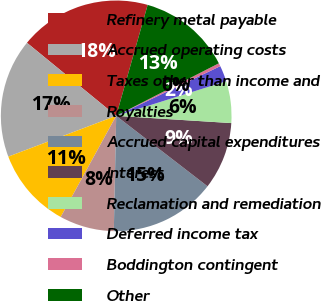Convert chart. <chart><loc_0><loc_0><loc_500><loc_500><pie_chart><fcel>Refinery metal payable<fcel>Accrued operating costs<fcel>Taxes other than income and<fcel>Royalties<fcel>Accrued capital expenditures<fcel>Interest<fcel>Reclamation and remediation<fcel>Deferred income tax<fcel>Boddington contingent<fcel>Other<nl><fcel>18.48%<fcel>16.67%<fcel>11.26%<fcel>7.66%<fcel>14.87%<fcel>9.46%<fcel>5.85%<fcel>2.24%<fcel>0.44%<fcel>13.07%<nl></chart> 